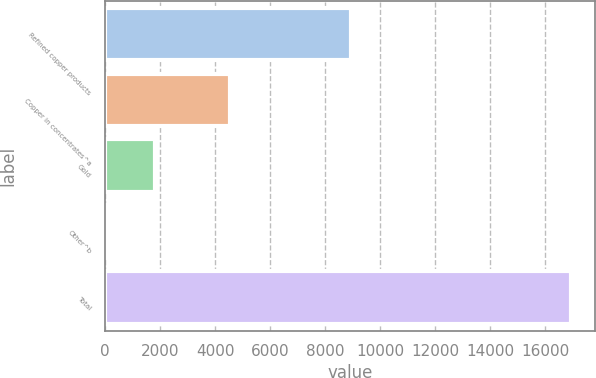<chart> <loc_0><loc_0><loc_500><loc_500><bar_chart><fcel>Refined copper products<fcel>Copper in concentrates^a<fcel>Gold<fcel>Other^b<fcel>Total<nl><fcel>8918<fcel>4541<fcel>1795.6<fcel>113<fcel>16939<nl></chart> 